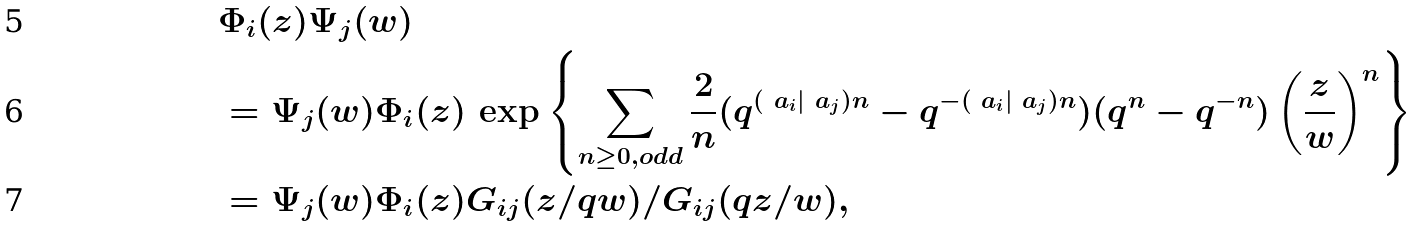Convert formula to latex. <formula><loc_0><loc_0><loc_500><loc_500>& \Phi _ { i } ( z ) \Psi _ { j } ( w ) \\ & = \Psi _ { j } ( w ) \Phi _ { i } ( z ) \, \exp \left \{ \sum _ { n \geq 0 , o d d } \frac { 2 } { n } ( q ^ { ( \ a _ { i } | \ a _ { j } ) n } - q ^ { - ( \ a _ { i } | \ a _ { j } ) n } ) ( q ^ { n } - q ^ { - n } ) \left ( \frac { z } { w } \right ) ^ { n } \right \} \\ & = \Psi _ { j } ( w ) \Phi _ { i } ( z ) G _ { i j } ( z / q w ) / G _ { i j } ( q z / w ) ,</formula> 